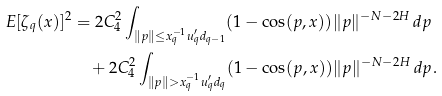Convert formula to latex. <formula><loc_0><loc_0><loc_500><loc_500>E [ \zeta _ { q } ( x ) ] ^ { 2 } & = 2 C ^ { 2 } _ { 4 } \int _ { \| p \| \leq x ^ { - 1 } _ { q } u ^ { \prime } _ { q } d _ { q - 1 } } ( 1 - \cos ( p , x ) ) \| p \| ^ { - N - 2 H } \, d p \\ & \quad + 2 C ^ { 2 } _ { 4 } \int _ { \| p \| > x ^ { - 1 } _ { q } u ^ { \prime } _ { q } d _ { q } } ( 1 - \cos ( p , x ) ) \| p \| ^ { - N - 2 H } \, d p .</formula> 